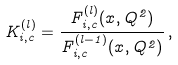<formula> <loc_0><loc_0><loc_500><loc_500>K _ { i , c } ^ { ( l ) } = \frac { F _ { i , c } ^ { ( l ) } ( x , Q ^ { 2 } ) } { F _ { i , c } ^ { ( l - 1 ) } ( x , Q ^ { 2 } ) } \, ,</formula> 